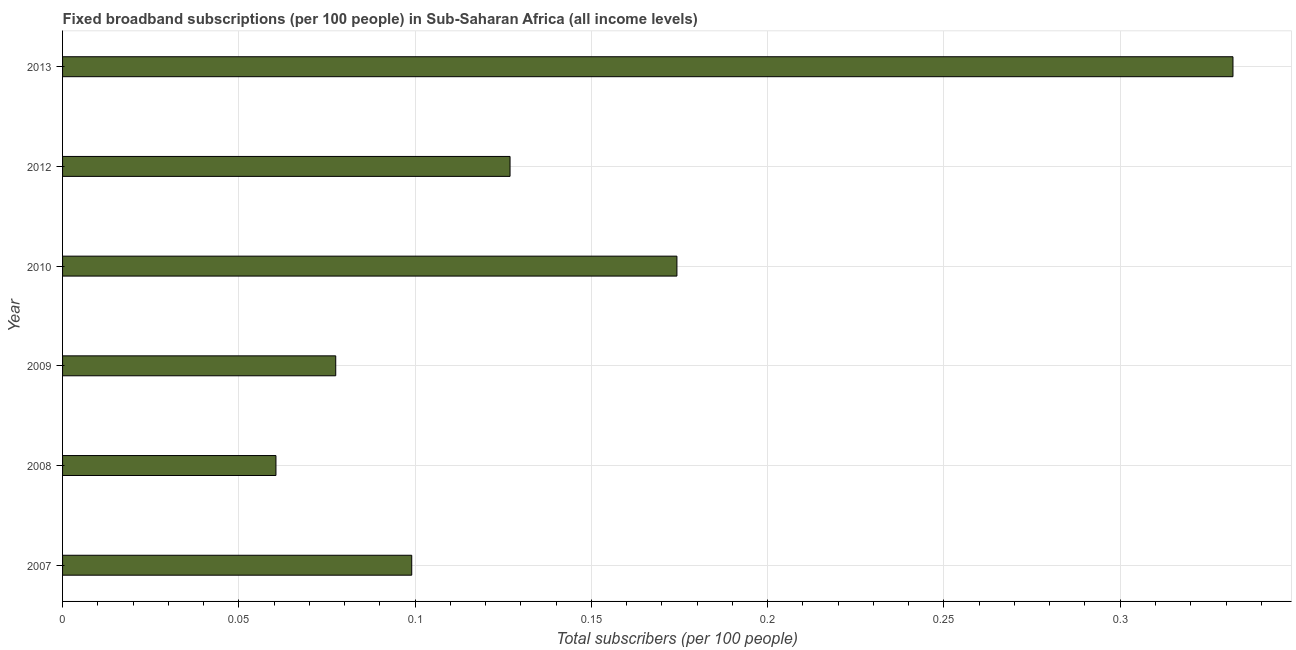Does the graph contain any zero values?
Provide a short and direct response. No. Does the graph contain grids?
Your answer should be compact. Yes. What is the title of the graph?
Ensure brevity in your answer.  Fixed broadband subscriptions (per 100 people) in Sub-Saharan Africa (all income levels). What is the label or title of the X-axis?
Your answer should be compact. Total subscribers (per 100 people). What is the label or title of the Y-axis?
Make the answer very short. Year. What is the total number of fixed broadband subscriptions in 2007?
Keep it short and to the point. 0.1. Across all years, what is the maximum total number of fixed broadband subscriptions?
Offer a very short reply. 0.33. Across all years, what is the minimum total number of fixed broadband subscriptions?
Your answer should be very brief. 0.06. In which year was the total number of fixed broadband subscriptions maximum?
Provide a succinct answer. 2013. What is the sum of the total number of fixed broadband subscriptions?
Ensure brevity in your answer.  0.87. What is the difference between the total number of fixed broadband subscriptions in 2009 and 2013?
Offer a very short reply. -0.25. What is the average total number of fixed broadband subscriptions per year?
Ensure brevity in your answer.  0.14. What is the median total number of fixed broadband subscriptions?
Your answer should be compact. 0.11. In how many years, is the total number of fixed broadband subscriptions greater than 0.05 ?
Keep it short and to the point. 6. Do a majority of the years between 2010 and 2007 (inclusive) have total number of fixed broadband subscriptions greater than 0.01 ?
Keep it short and to the point. Yes. What is the ratio of the total number of fixed broadband subscriptions in 2007 to that in 2009?
Provide a succinct answer. 1.28. What is the difference between the highest and the second highest total number of fixed broadband subscriptions?
Your answer should be compact. 0.16. What is the difference between the highest and the lowest total number of fixed broadband subscriptions?
Your answer should be compact. 0.27. In how many years, is the total number of fixed broadband subscriptions greater than the average total number of fixed broadband subscriptions taken over all years?
Provide a succinct answer. 2. How many bars are there?
Keep it short and to the point. 6. Are all the bars in the graph horizontal?
Provide a succinct answer. Yes. How many years are there in the graph?
Provide a short and direct response. 6. Are the values on the major ticks of X-axis written in scientific E-notation?
Provide a short and direct response. No. What is the Total subscribers (per 100 people) of 2007?
Your answer should be very brief. 0.1. What is the Total subscribers (per 100 people) in 2008?
Provide a succinct answer. 0.06. What is the Total subscribers (per 100 people) of 2009?
Keep it short and to the point. 0.08. What is the Total subscribers (per 100 people) in 2010?
Provide a short and direct response. 0.17. What is the Total subscribers (per 100 people) of 2012?
Provide a succinct answer. 0.13. What is the Total subscribers (per 100 people) in 2013?
Keep it short and to the point. 0.33. What is the difference between the Total subscribers (per 100 people) in 2007 and 2008?
Provide a short and direct response. 0.04. What is the difference between the Total subscribers (per 100 people) in 2007 and 2009?
Give a very brief answer. 0.02. What is the difference between the Total subscribers (per 100 people) in 2007 and 2010?
Keep it short and to the point. -0.08. What is the difference between the Total subscribers (per 100 people) in 2007 and 2012?
Your answer should be very brief. -0.03. What is the difference between the Total subscribers (per 100 people) in 2007 and 2013?
Offer a terse response. -0.23. What is the difference between the Total subscribers (per 100 people) in 2008 and 2009?
Provide a succinct answer. -0.02. What is the difference between the Total subscribers (per 100 people) in 2008 and 2010?
Offer a terse response. -0.11. What is the difference between the Total subscribers (per 100 people) in 2008 and 2012?
Provide a succinct answer. -0.07. What is the difference between the Total subscribers (per 100 people) in 2008 and 2013?
Your answer should be compact. -0.27. What is the difference between the Total subscribers (per 100 people) in 2009 and 2010?
Keep it short and to the point. -0.1. What is the difference between the Total subscribers (per 100 people) in 2009 and 2012?
Your response must be concise. -0.05. What is the difference between the Total subscribers (per 100 people) in 2009 and 2013?
Your answer should be very brief. -0.25. What is the difference between the Total subscribers (per 100 people) in 2010 and 2012?
Offer a terse response. 0.05. What is the difference between the Total subscribers (per 100 people) in 2010 and 2013?
Your answer should be very brief. -0.16. What is the difference between the Total subscribers (per 100 people) in 2012 and 2013?
Your answer should be very brief. -0.21. What is the ratio of the Total subscribers (per 100 people) in 2007 to that in 2008?
Ensure brevity in your answer.  1.64. What is the ratio of the Total subscribers (per 100 people) in 2007 to that in 2009?
Make the answer very short. 1.28. What is the ratio of the Total subscribers (per 100 people) in 2007 to that in 2010?
Keep it short and to the point. 0.57. What is the ratio of the Total subscribers (per 100 people) in 2007 to that in 2012?
Give a very brief answer. 0.78. What is the ratio of the Total subscribers (per 100 people) in 2007 to that in 2013?
Your answer should be compact. 0.3. What is the ratio of the Total subscribers (per 100 people) in 2008 to that in 2009?
Your answer should be very brief. 0.78. What is the ratio of the Total subscribers (per 100 people) in 2008 to that in 2010?
Provide a succinct answer. 0.35. What is the ratio of the Total subscribers (per 100 people) in 2008 to that in 2012?
Your answer should be compact. 0.48. What is the ratio of the Total subscribers (per 100 people) in 2008 to that in 2013?
Ensure brevity in your answer.  0.18. What is the ratio of the Total subscribers (per 100 people) in 2009 to that in 2010?
Give a very brief answer. 0.45. What is the ratio of the Total subscribers (per 100 people) in 2009 to that in 2012?
Give a very brief answer. 0.61. What is the ratio of the Total subscribers (per 100 people) in 2009 to that in 2013?
Ensure brevity in your answer.  0.23. What is the ratio of the Total subscribers (per 100 people) in 2010 to that in 2012?
Provide a short and direct response. 1.37. What is the ratio of the Total subscribers (per 100 people) in 2010 to that in 2013?
Your response must be concise. 0.53. What is the ratio of the Total subscribers (per 100 people) in 2012 to that in 2013?
Offer a very short reply. 0.38. 